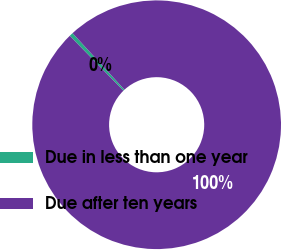Convert chart. <chart><loc_0><loc_0><loc_500><loc_500><pie_chart><fcel>Due in less than one year<fcel>Due after ten years<nl><fcel>0.49%<fcel>99.51%<nl></chart> 